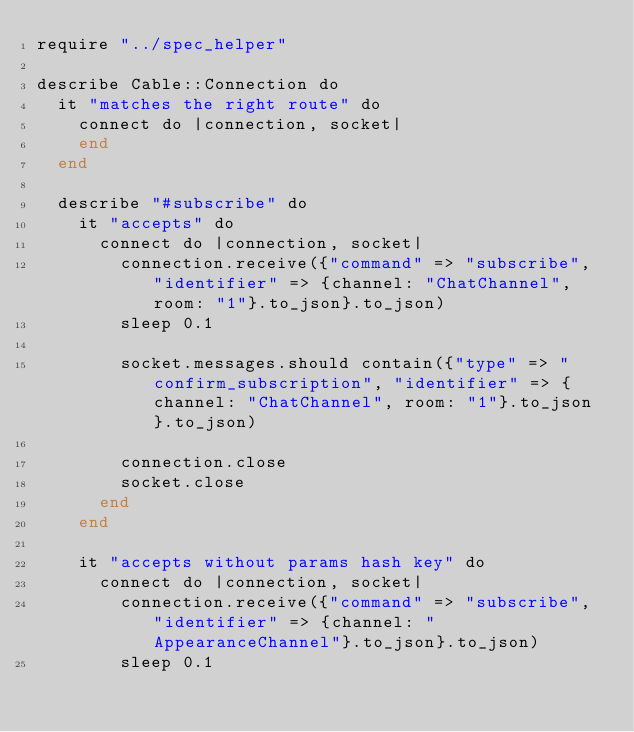<code> <loc_0><loc_0><loc_500><loc_500><_Crystal_>require "../spec_helper"

describe Cable::Connection do
  it "matches the right route" do
    connect do |connection, socket|
    end
  end

  describe "#subscribe" do
    it "accepts" do
      connect do |connection, socket|
        connection.receive({"command" => "subscribe", "identifier" => {channel: "ChatChannel", room: "1"}.to_json}.to_json)
        sleep 0.1

        socket.messages.should contain({"type" => "confirm_subscription", "identifier" => {channel: "ChatChannel", room: "1"}.to_json}.to_json)

        connection.close
        socket.close
      end
    end

    it "accepts without params hash key" do
      connect do |connection, socket|
        connection.receive({"command" => "subscribe", "identifier" => {channel: "AppearanceChannel"}.to_json}.to_json)
        sleep 0.1
</code> 